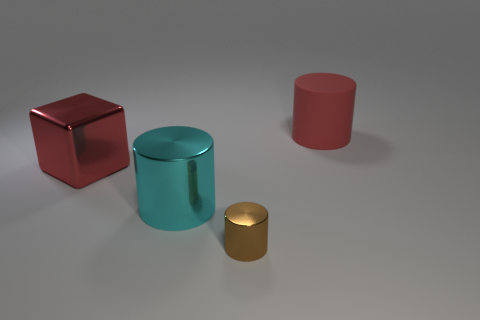Subtract all small metal cylinders. How many cylinders are left? 2 Add 2 small purple matte cylinders. How many objects exist? 6 Subtract all red cylinders. How many cylinders are left? 2 Subtract all cylinders. How many objects are left? 1 Subtract 2 cylinders. How many cylinders are left? 1 Add 1 brown things. How many brown things are left? 2 Add 1 cyan shiny things. How many cyan shiny things exist? 2 Subtract 0 cyan spheres. How many objects are left? 4 Subtract all brown cylinders. Subtract all brown blocks. How many cylinders are left? 2 Subtract all green balls. How many brown cylinders are left? 1 